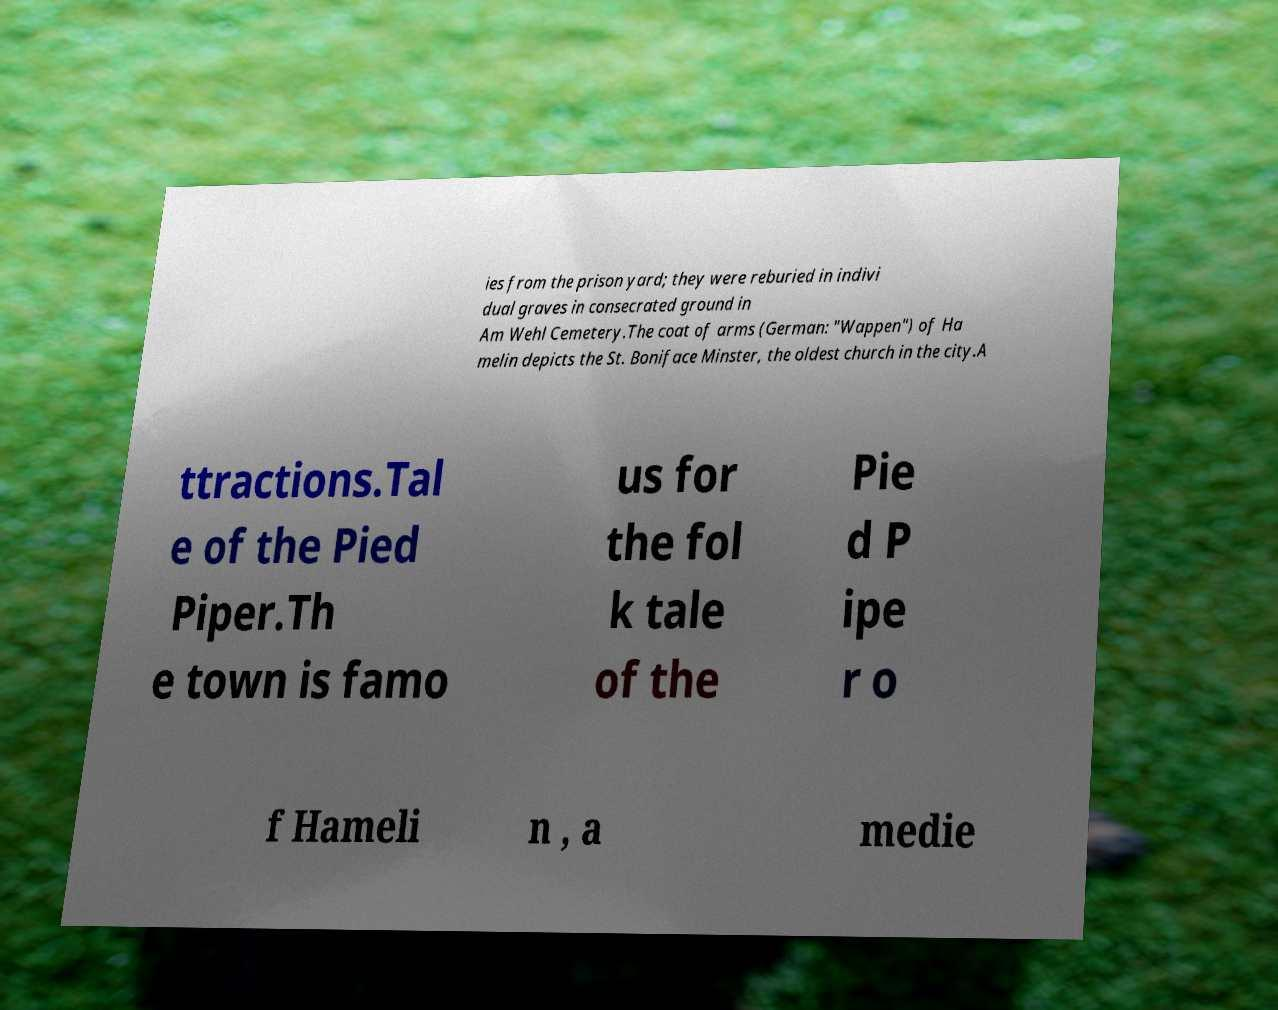Could you assist in decoding the text presented in this image and type it out clearly? ies from the prison yard; they were reburied in indivi dual graves in consecrated ground in Am Wehl Cemetery.The coat of arms (German: "Wappen") of Ha melin depicts the St. Boniface Minster, the oldest church in the city.A ttractions.Tal e of the Pied Piper.Th e town is famo us for the fol k tale of the Pie d P ipe r o f Hameli n , a medie 